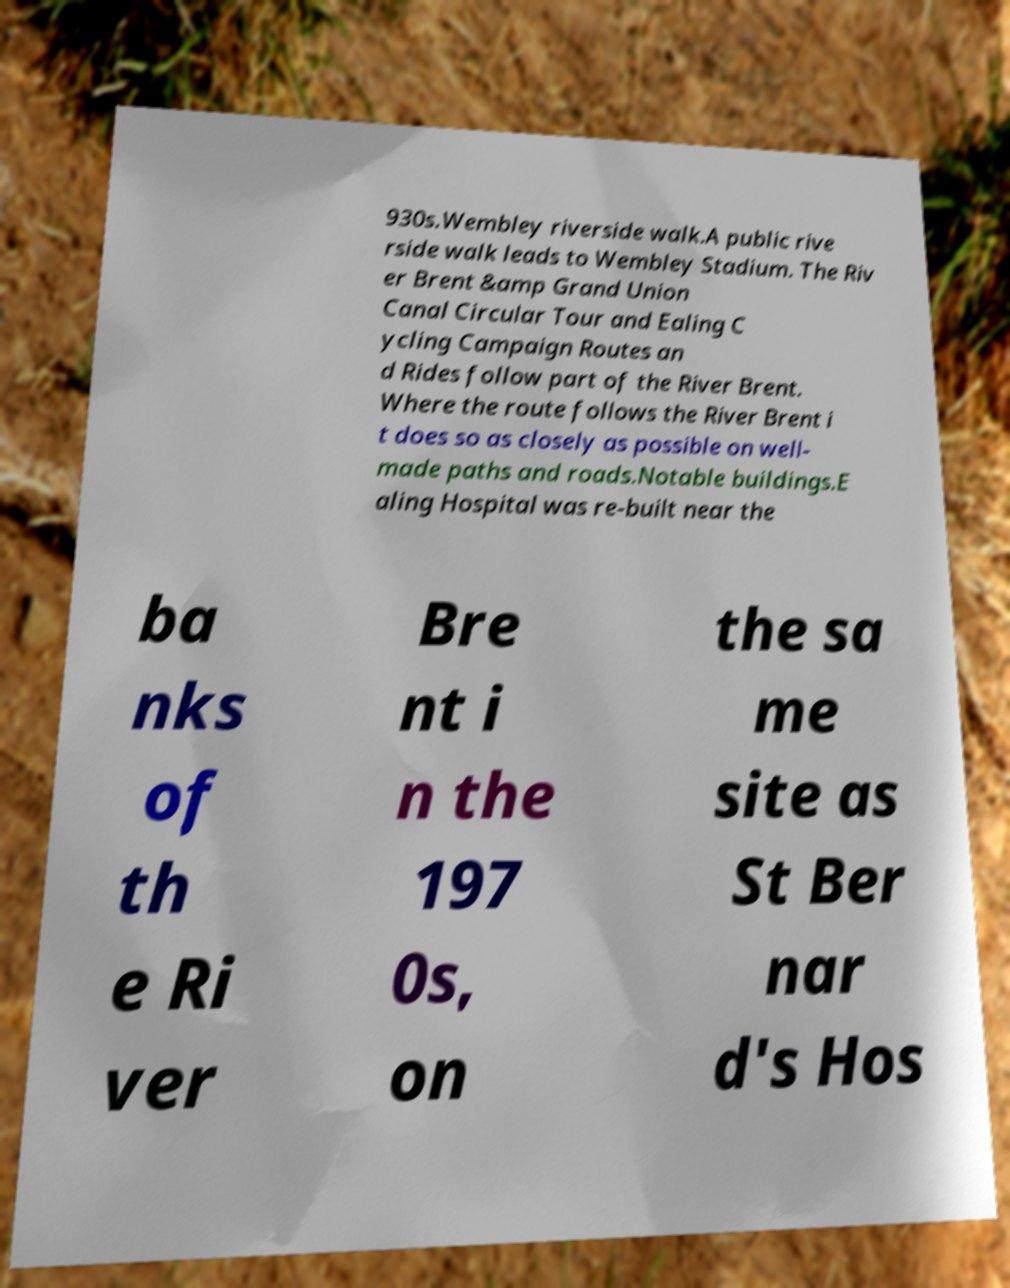There's text embedded in this image that I need extracted. Can you transcribe it verbatim? 930s.Wembley riverside walk.A public rive rside walk leads to Wembley Stadium. The Riv er Brent &amp Grand Union Canal Circular Tour and Ealing C ycling Campaign Routes an d Rides follow part of the River Brent. Where the route follows the River Brent i t does so as closely as possible on well- made paths and roads.Notable buildings.E aling Hospital was re-built near the ba nks of th e Ri ver Bre nt i n the 197 0s, on the sa me site as St Ber nar d's Hos 